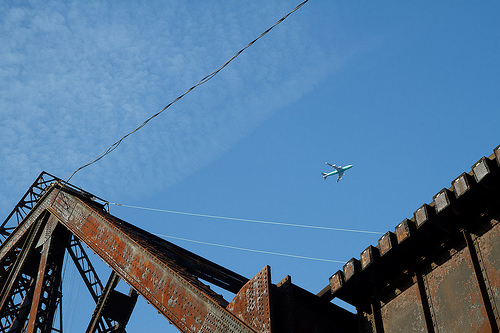Describe a creative scenario involving this bridge. Imagine this bridge as a portal to another world. As you step onto it, the rusted steel beams shimmer and the structure transforms into a gleaming metal pathway suspended over a galaxy filled with stars. Each beam glows with an otherworldly light, guiding you to an unknown but thrilling destination. What kind of maintenance might this bridge need? This bridge likely needs significant maintenance due to visible rust and potential structural weakening. Tasks might include sandblasting the steel beams to remove rust, applying anti-corrosive treatments and fresh paint, and inspecting all junctions and fasteners to ensure they are secure and replacing any that are damaged. How might weather affect the bridge structure? Harsh weather conditions like heavy rain, snow, and wind can exacerbate the rusting and further weaken the structural integrity of the bridge. Regular exposure to moisture can lead to corrosion of the steel components, while high winds could stress the connections and fastenings. Keeping the bridge well-maintained and regularly inspected is essential to ensure safety. 